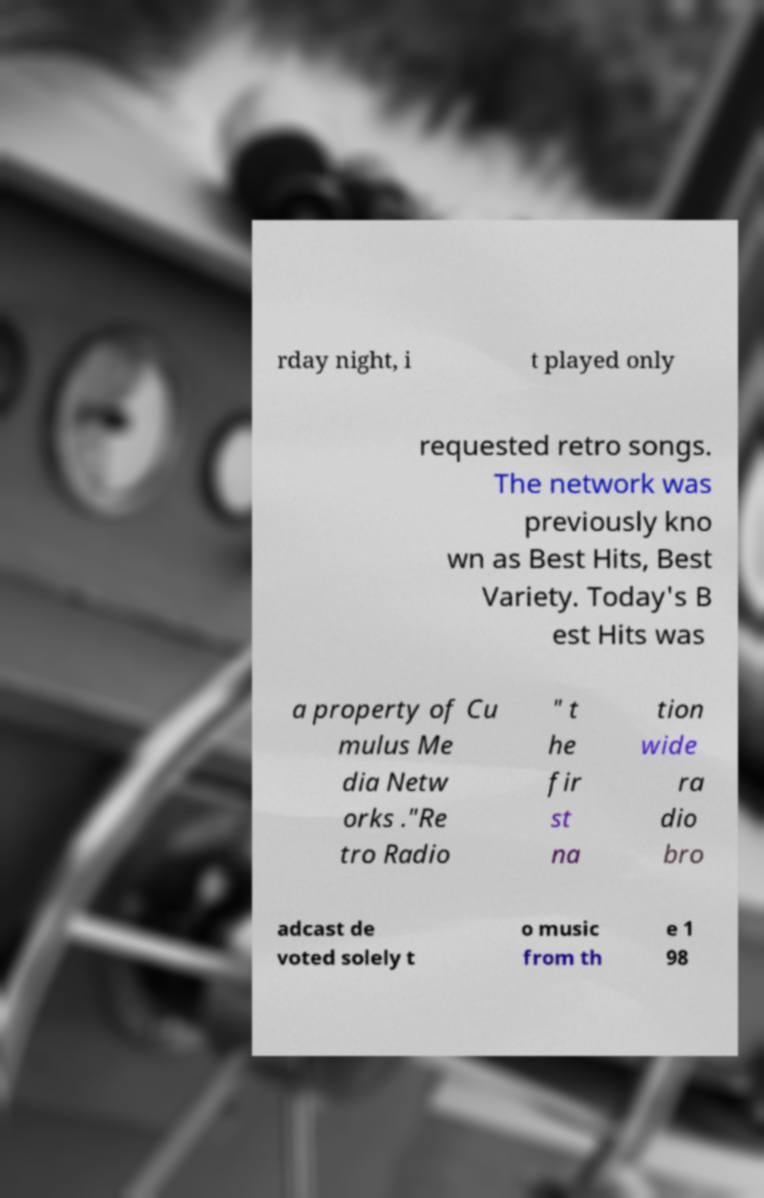Could you assist in decoding the text presented in this image and type it out clearly? rday night, i t played only requested retro songs. The network was previously kno wn as Best Hits, Best Variety. Today's B est Hits was a property of Cu mulus Me dia Netw orks ."Re tro Radio " t he fir st na tion wide ra dio bro adcast de voted solely t o music from th e 1 98 